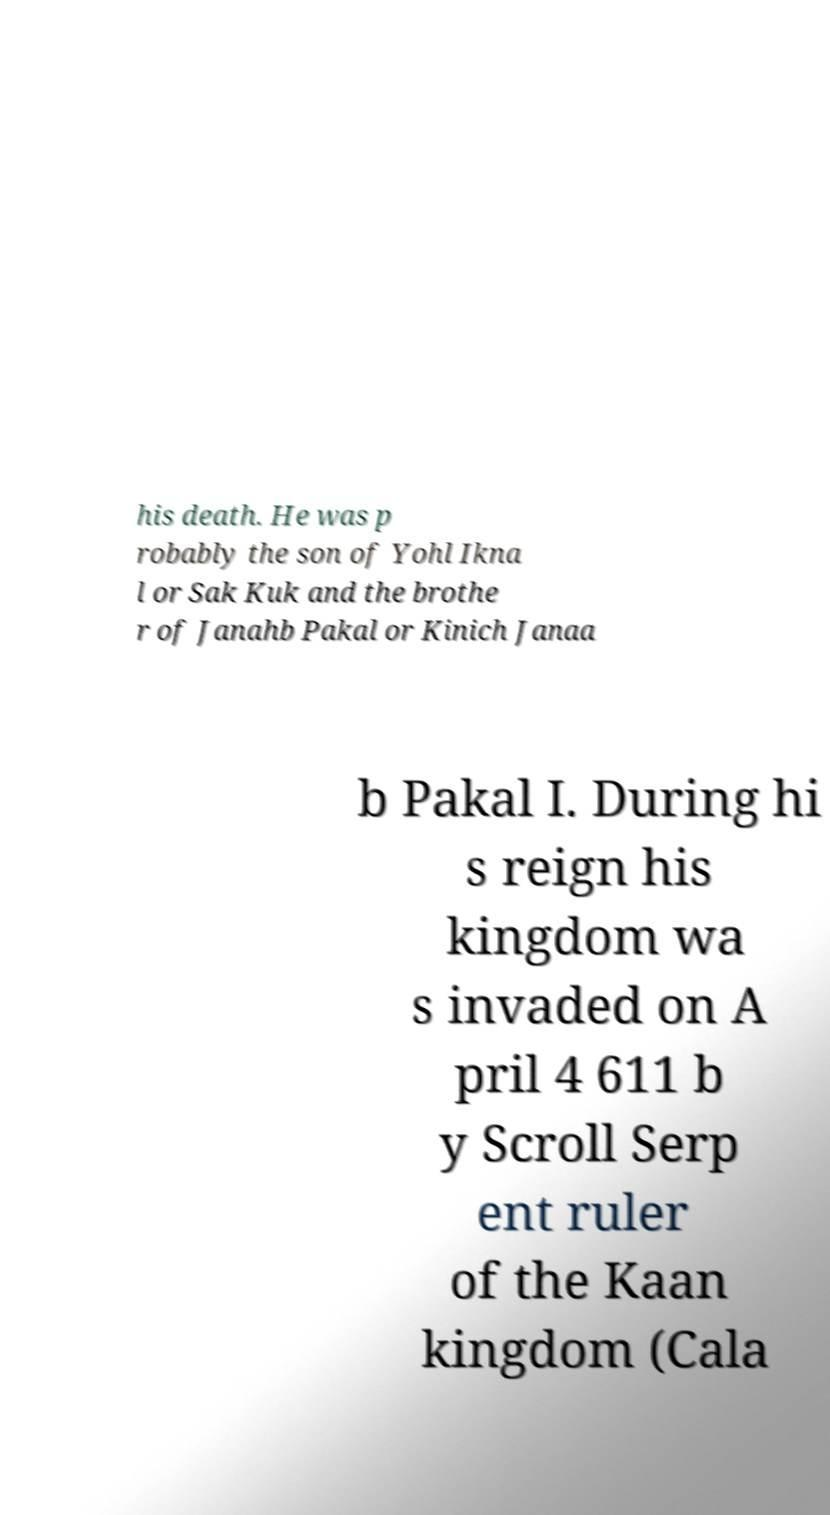Can you accurately transcribe the text from the provided image for me? his death. He was p robably the son of Yohl Ikna l or Sak Kuk and the brothe r of Janahb Pakal or Kinich Janaa b Pakal I. During hi s reign his kingdom wa s invaded on A pril 4 611 b y Scroll Serp ent ruler of the Kaan kingdom (Cala 